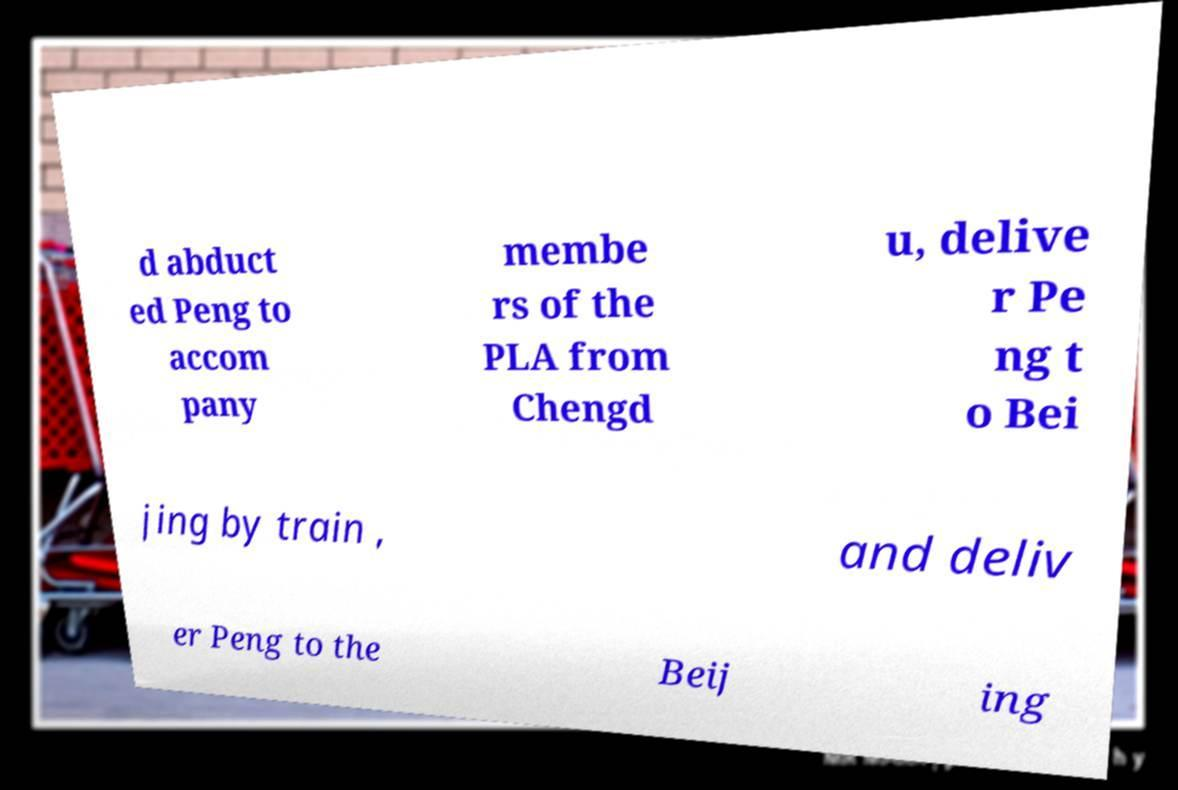What messages or text are displayed in this image? I need them in a readable, typed format. d abduct ed Peng to accom pany membe rs of the PLA from Chengd u, delive r Pe ng t o Bei jing by train , and deliv er Peng to the Beij ing 